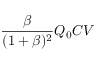Convert formula to latex. <formula><loc_0><loc_0><loc_500><loc_500>\frac { \beta } { ( 1 + \beta ) ^ { 2 } } Q _ { 0 } C V</formula> 